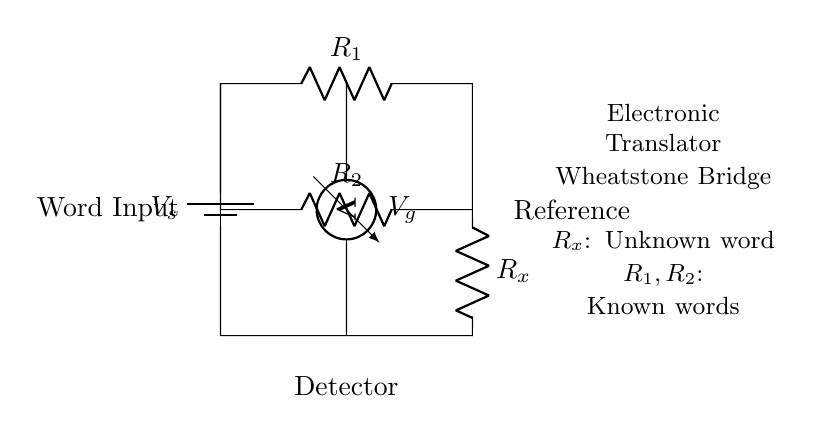What is the type of circuit shown? The circuit shown is a Wheatstone bridge, which is characterized by its arrangement of resistors and is used for measuring unknown resistances.
Answer: Wheatstone bridge What does R_x represent? R_x represents the unknown resistance that corresponds to a specific word input in the electronic translator.
Answer: Unknown word What is the role of V_s in this circuit? V_s is the source voltage that drives the current through the circuit, providing the necessary potential difference for operation.
Answer: Source voltage How many resistors are in the circuit? There are three resistors in the circuit: R_1, R_2, and R_x.
Answer: Three What is measured by the voltmeter? The voltmeter measures the voltage difference across the bridge, indicating whether the bridge is balanced or needs adjustment.
Answer: Voltage difference Why is a Wheatstone bridge used in electronic translators? A Wheatstone bridge is used for precise balance and measurement of unknown resistances, allowing accurate detection of word inputs based on electrical resistance changes.
Answer: Accurate word detection 